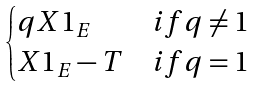<formula> <loc_0><loc_0><loc_500><loc_500>\begin{cases} q X 1 _ { E } & i f q \not = 1 \\ X 1 _ { E } - T & i f q = 1 \end{cases}</formula> 